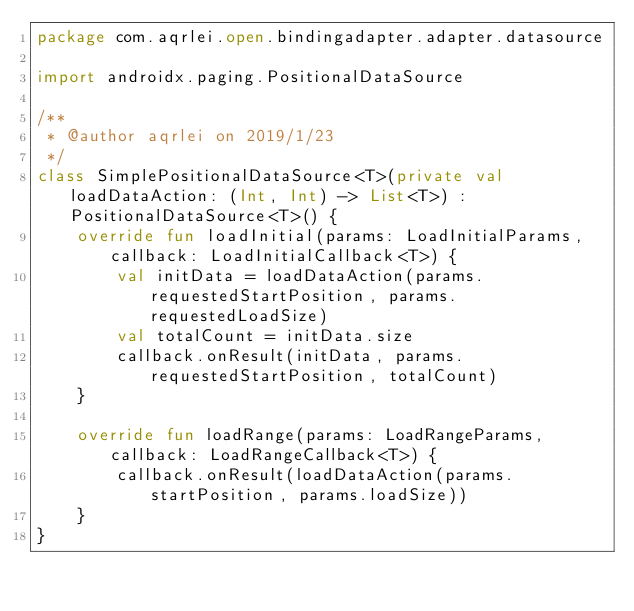<code> <loc_0><loc_0><loc_500><loc_500><_Kotlin_>package com.aqrlei.open.bindingadapter.adapter.datasource

import androidx.paging.PositionalDataSource

/**
 * @author aqrlei on 2019/1/23
 */
class SimplePositionalDataSource<T>(private val loadDataAction: (Int, Int) -> List<T>) : PositionalDataSource<T>() {
    override fun loadInitial(params: LoadInitialParams, callback: LoadInitialCallback<T>) {
        val initData = loadDataAction(params.requestedStartPosition, params.requestedLoadSize)
        val totalCount = initData.size
        callback.onResult(initData, params.requestedStartPosition, totalCount)
    }

    override fun loadRange(params: LoadRangeParams, callback: LoadRangeCallback<T>) {
        callback.onResult(loadDataAction(params.startPosition, params.loadSize))
    }
}</code> 